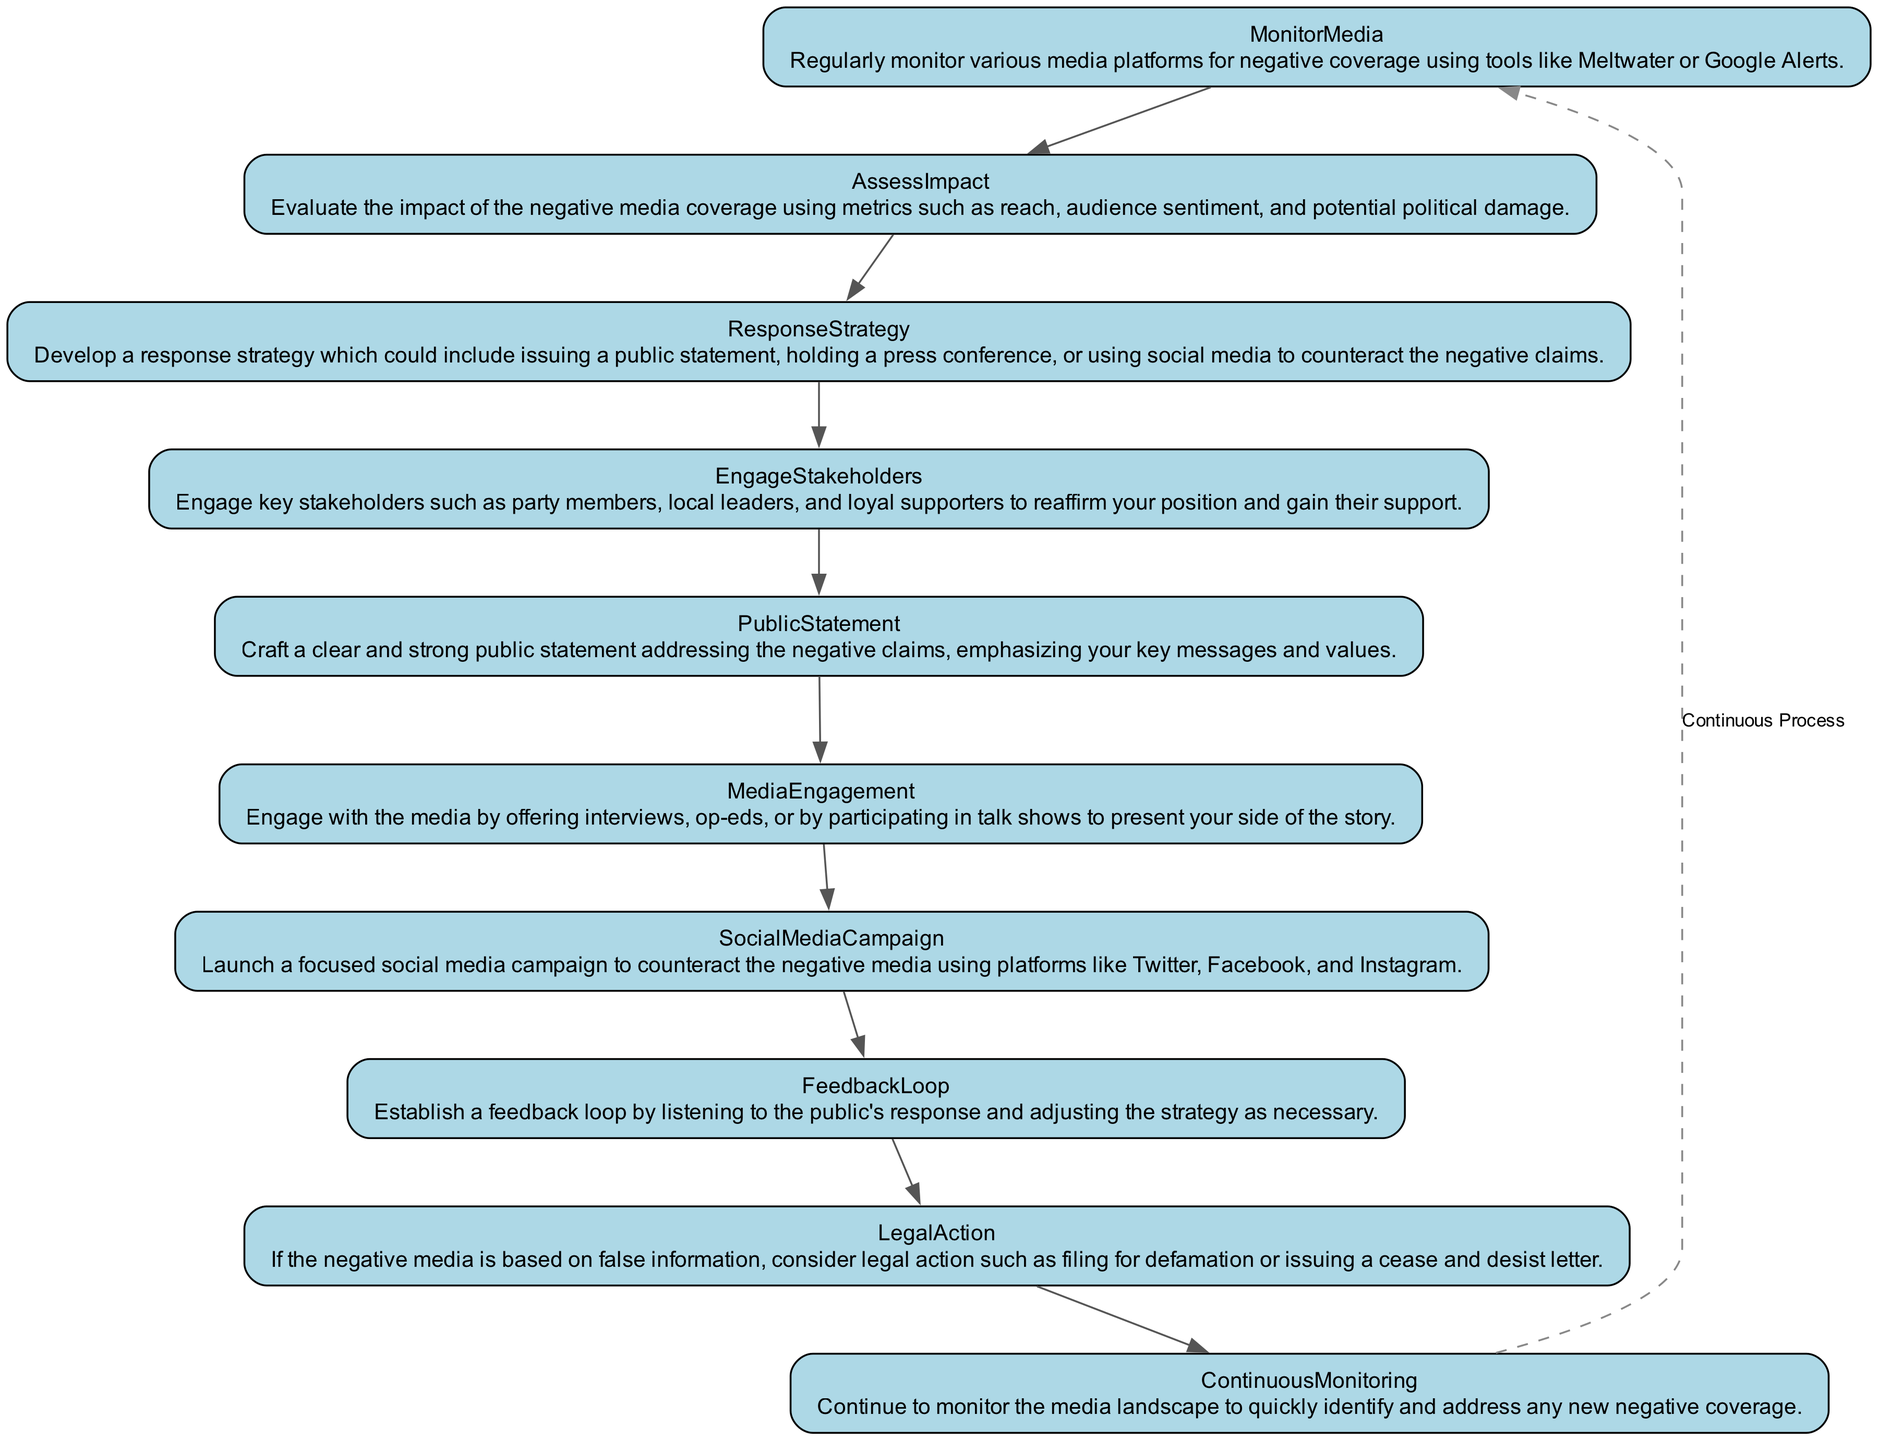What is the first step in managing a negative media campaign? The first step listed in the diagram is "MonitorMedia," which involves regularly checking media platforms for negative coverage.
Answer: MonitorMedia How many steps are outlined in the diagram? By counting each unique step listed in the diagram, we find that there are ten steps in total.
Answer: 10 What follows after assessing the impact of the negative media coverage? According to the flow, after the "AssessImpact" step, the next step is "ResponseStrategy."
Answer: ResponseStrategy What is the main objective of the "EngageStakeholders" step? The purpose of engaging stakeholders is to reaffirm the politician's position and gain support from key individuals.
Answer: Reaffirm position and gain support If false information is present in the negative media, which step could be considered? The diagram suggests "LegalAction" as a possible step if the negative media is based on false information.
Answer: LegalAction What loop is established at the end of the flow? A "FeedbackLoop" is established to listen to public responses and adjust strategies accordingly.
Answer: FeedbackLoop What is the last step that leads back to the beginning of the process? The last step, "ContinuousMonitoring," leads back to the initial step, forming a cycle in the process.
Answer: ContinuousMonitoring Which step involves crafting a public statement? The step that specifically involves creating a public response is labeled "PublicStatement."
Answer: PublicStatement What strategy could be utilized for counteracting negative media via social platforms? The diagram indicates launching a "SocialMediaCampaign" as a strategy to address negative media on platforms like Twitter and Facebook.
Answer: SocialMediaCampaign 